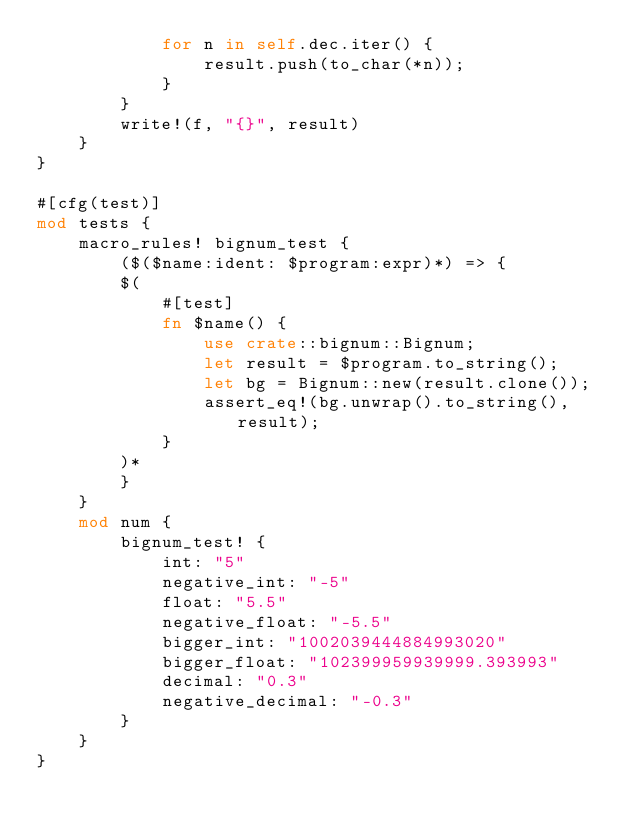Convert code to text. <code><loc_0><loc_0><loc_500><loc_500><_Rust_>            for n in self.dec.iter() {
                result.push(to_char(*n));
            }
        }
        write!(f, "{}", result)
    }
}

#[cfg(test)]
mod tests {
    macro_rules! bignum_test {
        ($($name:ident: $program:expr)*) => {
        $(
            #[test]
            fn $name() {
                use crate::bignum::Bignum;
                let result = $program.to_string();
                let bg = Bignum::new(result.clone());
                assert_eq!(bg.unwrap().to_string(), result);
            }
        )*
        }
    }
    mod num {
        bignum_test! {
            int: "5"
            negative_int: "-5"
            float: "5.5"
            negative_float: "-5.5"
            bigger_int: "1002039444884993020"
            bigger_float: "102399959939999.393993"
            decimal: "0.3"
            negative_decimal: "-0.3"
        }
    }
}
</code> 